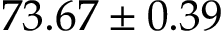<formula> <loc_0><loc_0><loc_500><loc_500>7 3 . 6 7 \pm 0 . 3 9</formula> 